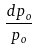Convert formula to latex. <formula><loc_0><loc_0><loc_500><loc_500>\frac { d p _ { o } } { p _ { o } }</formula> 